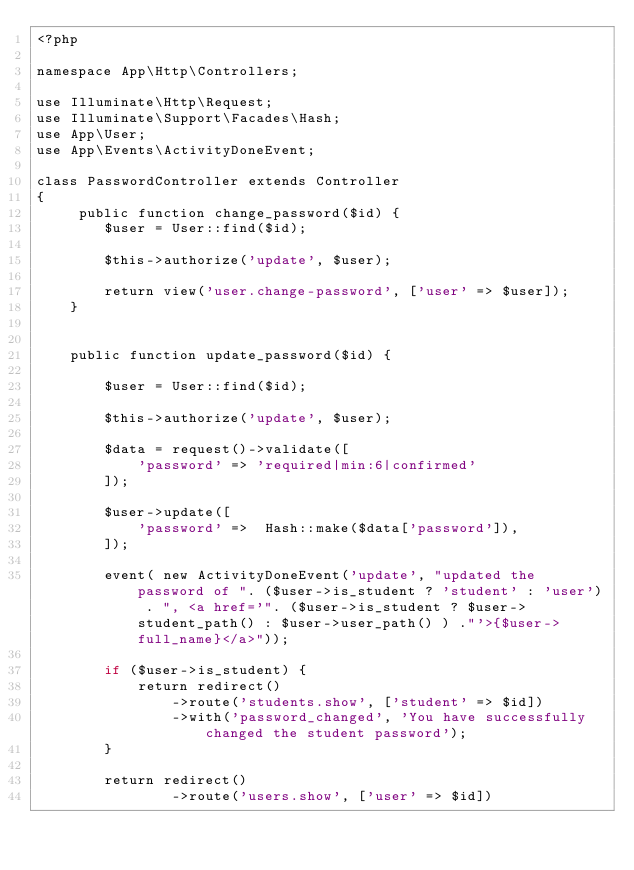<code> <loc_0><loc_0><loc_500><loc_500><_PHP_><?php

namespace App\Http\Controllers;

use Illuminate\Http\Request;
use Illuminate\Support\Facades\Hash;
use App\User;
use App\Events\ActivityDoneEvent;

class PasswordController extends Controller
{
     public function change_password($id) {
        $user = User::find($id);

        $this->authorize('update', $user);

        return view('user.change-password', ['user' => $user]);
    }


    public function update_password($id) {

        $user = User::find($id);

        $this->authorize('update', $user);

        $data = request()->validate([
            'password' => 'required|min:6|confirmed'
        ]);
        
        $user->update([
            'password' =>  Hash::make($data['password']),
        ]);

        event( new ActivityDoneEvent('update', "updated the password of ". ($user->is_student ? 'student' : 'user') . ", <a href='". ($user->is_student ? $user->student_path() : $user->user_path() ) ."'>{$user->full_name}</a>"));

        if ($user->is_student) {
        	  return redirect()
                ->route('students.show', ['student' => $id])
                ->with('password_changed', 'You have successfully changed the student password');
        } 

        return redirect()
                ->route('users.show', ['user' => $id])</code> 